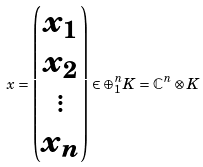<formula> <loc_0><loc_0><loc_500><loc_500>x = \begin{pmatrix} x _ { 1 } \\ x _ { 2 } \\ \vdots \\ x _ { n } \end{pmatrix} \in \oplus _ { 1 } ^ { n } K = \mathbb { C } ^ { n } \otimes K</formula> 